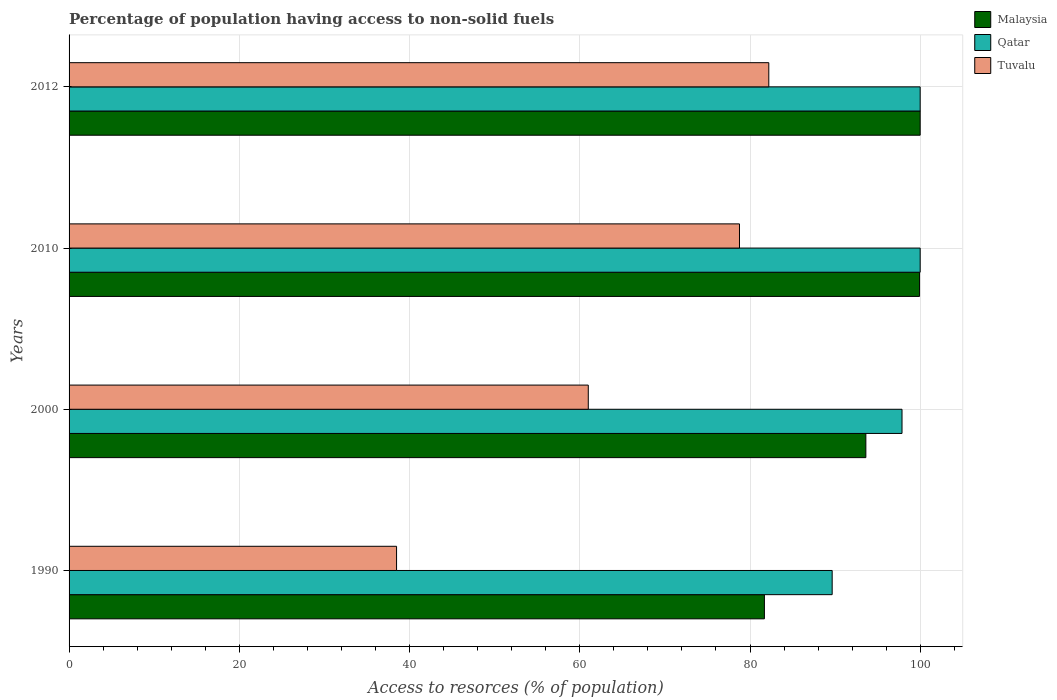How many different coloured bars are there?
Offer a very short reply. 3. How many groups of bars are there?
Provide a short and direct response. 4. How many bars are there on the 4th tick from the top?
Your answer should be very brief. 3. What is the label of the 2nd group of bars from the top?
Provide a short and direct response. 2010. In how many cases, is the number of bars for a given year not equal to the number of legend labels?
Offer a terse response. 0. What is the percentage of population having access to non-solid fuels in Malaysia in 2000?
Ensure brevity in your answer.  93.61. Across all years, what is the maximum percentage of population having access to non-solid fuels in Malaysia?
Provide a succinct answer. 99.99. Across all years, what is the minimum percentage of population having access to non-solid fuels in Tuvalu?
Offer a terse response. 38.47. In which year was the percentage of population having access to non-solid fuels in Qatar maximum?
Ensure brevity in your answer.  2010. In which year was the percentage of population having access to non-solid fuels in Qatar minimum?
Your answer should be compact. 1990. What is the total percentage of population having access to non-solid fuels in Qatar in the graph?
Offer a very short reply. 387.49. What is the difference between the percentage of population having access to non-solid fuels in Qatar in 2010 and that in 2012?
Provide a succinct answer. 0. What is the difference between the percentage of population having access to non-solid fuels in Qatar in 2010 and the percentage of population having access to non-solid fuels in Tuvalu in 2000?
Ensure brevity in your answer.  38.99. What is the average percentage of population having access to non-solid fuels in Malaysia per year?
Offer a terse response. 93.8. In the year 2010, what is the difference between the percentage of population having access to non-solid fuels in Tuvalu and percentage of population having access to non-solid fuels in Malaysia?
Provide a short and direct response. -21.15. In how many years, is the percentage of population having access to non-solid fuels in Tuvalu greater than 80 %?
Provide a succinct answer. 1. What is the ratio of the percentage of population having access to non-solid fuels in Qatar in 2000 to that in 2012?
Your answer should be compact. 0.98. Is the percentage of population having access to non-solid fuels in Malaysia in 2000 less than that in 2012?
Offer a very short reply. Yes. What is the difference between the highest and the second highest percentage of population having access to non-solid fuels in Malaysia?
Make the answer very short. 0.07. What is the difference between the highest and the lowest percentage of population having access to non-solid fuels in Malaysia?
Offer a terse response. 18.3. In how many years, is the percentage of population having access to non-solid fuels in Tuvalu greater than the average percentage of population having access to non-solid fuels in Tuvalu taken over all years?
Offer a very short reply. 2. What does the 3rd bar from the top in 2012 represents?
Give a very brief answer. Malaysia. What does the 1st bar from the bottom in 2010 represents?
Your response must be concise. Malaysia. Is it the case that in every year, the sum of the percentage of population having access to non-solid fuels in Qatar and percentage of population having access to non-solid fuels in Tuvalu is greater than the percentage of population having access to non-solid fuels in Malaysia?
Your answer should be compact. Yes. How many bars are there?
Provide a short and direct response. 12. Are all the bars in the graph horizontal?
Offer a terse response. Yes. What is the difference between two consecutive major ticks on the X-axis?
Offer a terse response. 20. Are the values on the major ticks of X-axis written in scientific E-notation?
Your answer should be compact. No. Does the graph contain grids?
Provide a succinct answer. Yes. Where does the legend appear in the graph?
Your response must be concise. Top right. How are the legend labels stacked?
Ensure brevity in your answer.  Vertical. What is the title of the graph?
Your answer should be very brief. Percentage of population having access to non-solid fuels. What is the label or title of the X-axis?
Provide a short and direct response. Access to resorces (% of population). What is the label or title of the Y-axis?
Make the answer very short. Years. What is the Access to resorces (% of population) of Malaysia in 1990?
Offer a very short reply. 81.69. What is the Access to resorces (% of population) in Qatar in 1990?
Your answer should be compact. 89.65. What is the Access to resorces (% of population) in Tuvalu in 1990?
Provide a succinct answer. 38.47. What is the Access to resorces (% of population) in Malaysia in 2000?
Provide a succinct answer. 93.61. What is the Access to resorces (% of population) in Qatar in 2000?
Make the answer very short. 97.86. What is the Access to resorces (% of population) of Tuvalu in 2000?
Offer a very short reply. 61. What is the Access to resorces (% of population) of Malaysia in 2010?
Your answer should be compact. 99.92. What is the Access to resorces (% of population) in Qatar in 2010?
Make the answer very short. 99.99. What is the Access to resorces (% of population) in Tuvalu in 2010?
Give a very brief answer. 78.76. What is the Access to resorces (% of population) of Malaysia in 2012?
Your response must be concise. 99.99. What is the Access to resorces (% of population) of Qatar in 2012?
Provide a succinct answer. 99.99. What is the Access to resorces (% of population) in Tuvalu in 2012?
Make the answer very short. 82.21. Across all years, what is the maximum Access to resorces (% of population) of Malaysia?
Make the answer very short. 99.99. Across all years, what is the maximum Access to resorces (% of population) in Qatar?
Give a very brief answer. 99.99. Across all years, what is the maximum Access to resorces (% of population) in Tuvalu?
Offer a very short reply. 82.21. Across all years, what is the minimum Access to resorces (% of population) in Malaysia?
Your answer should be compact. 81.69. Across all years, what is the minimum Access to resorces (% of population) of Qatar?
Your answer should be very brief. 89.65. Across all years, what is the minimum Access to resorces (% of population) in Tuvalu?
Keep it short and to the point. 38.47. What is the total Access to resorces (% of population) in Malaysia in the graph?
Give a very brief answer. 375.21. What is the total Access to resorces (% of population) of Qatar in the graph?
Provide a succinct answer. 387.49. What is the total Access to resorces (% of population) in Tuvalu in the graph?
Keep it short and to the point. 260.44. What is the difference between the Access to resorces (% of population) in Malaysia in 1990 and that in 2000?
Your answer should be compact. -11.92. What is the difference between the Access to resorces (% of population) of Qatar in 1990 and that in 2000?
Provide a succinct answer. -8.21. What is the difference between the Access to resorces (% of population) in Tuvalu in 1990 and that in 2000?
Your answer should be compact. -22.52. What is the difference between the Access to resorces (% of population) in Malaysia in 1990 and that in 2010?
Offer a terse response. -18.23. What is the difference between the Access to resorces (% of population) in Qatar in 1990 and that in 2010?
Your answer should be compact. -10.34. What is the difference between the Access to resorces (% of population) of Tuvalu in 1990 and that in 2010?
Offer a very short reply. -40.29. What is the difference between the Access to resorces (% of population) in Malaysia in 1990 and that in 2012?
Offer a very short reply. -18.3. What is the difference between the Access to resorces (% of population) in Qatar in 1990 and that in 2012?
Provide a succinct answer. -10.34. What is the difference between the Access to resorces (% of population) in Tuvalu in 1990 and that in 2012?
Give a very brief answer. -43.73. What is the difference between the Access to resorces (% of population) of Malaysia in 2000 and that in 2010?
Offer a very short reply. -6.31. What is the difference between the Access to resorces (% of population) in Qatar in 2000 and that in 2010?
Make the answer very short. -2.13. What is the difference between the Access to resorces (% of population) in Tuvalu in 2000 and that in 2010?
Provide a succinct answer. -17.76. What is the difference between the Access to resorces (% of population) in Malaysia in 2000 and that in 2012?
Offer a very short reply. -6.38. What is the difference between the Access to resorces (% of population) of Qatar in 2000 and that in 2012?
Your answer should be very brief. -2.13. What is the difference between the Access to resorces (% of population) in Tuvalu in 2000 and that in 2012?
Your answer should be compact. -21.21. What is the difference between the Access to resorces (% of population) of Malaysia in 2010 and that in 2012?
Offer a very short reply. -0.07. What is the difference between the Access to resorces (% of population) of Tuvalu in 2010 and that in 2012?
Your response must be concise. -3.44. What is the difference between the Access to resorces (% of population) in Malaysia in 1990 and the Access to resorces (% of population) in Qatar in 2000?
Offer a very short reply. -16.17. What is the difference between the Access to resorces (% of population) in Malaysia in 1990 and the Access to resorces (% of population) in Tuvalu in 2000?
Keep it short and to the point. 20.69. What is the difference between the Access to resorces (% of population) in Qatar in 1990 and the Access to resorces (% of population) in Tuvalu in 2000?
Your answer should be very brief. 28.65. What is the difference between the Access to resorces (% of population) of Malaysia in 1990 and the Access to resorces (% of population) of Qatar in 2010?
Ensure brevity in your answer.  -18.3. What is the difference between the Access to resorces (% of population) of Malaysia in 1990 and the Access to resorces (% of population) of Tuvalu in 2010?
Your answer should be compact. 2.93. What is the difference between the Access to resorces (% of population) of Qatar in 1990 and the Access to resorces (% of population) of Tuvalu in 2010?
Your answer should be very brief. 10.89. What is the difference between the Access to resorces (% of population) in Malaysia in 1990 and the Access to resorces (% of population) in Qatar in 2012?
Your answer should be compact. -18.3. What is the difference between the Access to resorces (% of population) of Malaysia in 1990 and the Access to resorces (% of population) of Tuvalu in 2012?
Your answer should be compact. -0.51. What is the difference between the Access to resorces (% of population) of Qatar in 1990 and the Access to resorces (% of population) of Tuvalu in 2012?
Your answer should be very brief. 7.45. What is the difference between the Access to resorces (% of population) of Malaysia in 2000 and the Access to resorces (% of population) of Qatar in 2010?
Keep it short and to the point. -6.38. What is the difference between the Access to resorces (% of population) of Malaysia in 2000 and the Access to resorces (% of population) of Tuvalu in 2010?
Keep it short and to the point. 14.85. What is the difference between the Access to resorces (% of population) of Qatar in 2000 and the Access to resorces (% of population) of Tuvalu in 2010?
Offer a very short reply. 19.1. What is the difference between the Access to resorces (% of population) of Malaysia in 2000 and the Access to resorces (% of population) of Qatar in 2012?
Provide a succinct answer. -6.38. What is the difference between the Access to resorces (% of population) of Malaysia in 2000 and the Access to resorces (% of population) of Tuvalu in 2012?
Offer a terse response. 11.4. What is the difference between the Access to resorces (% of population) of Qatar in 2000 and the Access to resorces (% of population) of Tuvalu in 2012?
Ensure brevity in your answer.  15.65. What is the difference between the Access to resorces (% of population) of Malaysia in 2010 and the Access to resorces (% of population) of Qatar in 2012?
Your response must be concise. -0.07. What is the difference between the Access to resorces (% of population) in Malaysia in 2010 and the Access to resorces (% of population) in Tuvalu in 2012?
Ensure brevity in your answer.  17.71. What is the difference between the Access to resorces (% of population) in Qatar in 2010 and the Access to resorces (% of population) in Tuvalu in 2012?
Your answer should be very brief. 17.78. What is the average Access to resorces (% of population) of Malaysia per year?
Your answer should be compact. 93.8. What is the average Access to resorces (% of population) of Qatar per year?
Your answer should be compact. 96.87. What is the average Access to resorces (% of population) of Tuvalu per year?
Your answer should be compact. 65.11. In the year 1990, what is the difference between the Access to resorces (% of population) of Malaysia and Access to resorces (% of population) of Qatar?
Give a very brief answer. -7.96. In the year 1990, what is the difference between the Access to resorces (% of population) of Malaysia and Access to resorces (% of population) of Tuvalu?
Your answer should be very brief. 43.22. In the year 1990, what is the difference between the Access to resorces (% of population) of Qatar and Access to resorces (% of population) of Tuvalu?
Give a very brief answer. 51.18. In the year 2000, what is the difference between the Access to resorces (% of population) in Malaysia and Access to resorces (% of population) in Qatar?
Give a very brief answer. -4.25. In the year 2000, what is the difference between the Access to resorces (% of population) of Malaysia and Access to resorces (% of population) of Tuvalu?
Offer a very short reply. 32.61. In the year 2000, what is the difference between the Access to resorces (% of population) of Qatar and Access to resorces (% of population) of Tuvalu?
Give a very brief answer. 36.86. In the year 2010, what is the difference between the Access to resorces (% of population) of Malaysia and Access to resorces (% of population) of Qatar?
Offer a very short reply. -0.07. In the year 2010, what is the difference between the Access to resorces (% of population) of Malaysia and Access to resorces (% of population) of Tuvalu?
Your response must be concise. 21.15. In the year 2010, what is the difference between the Access to resorces (% of population) of Qatar and Access to resorces (% of population) of Tuvalu?
Ensure brevity in your answer.  21.23. In the year 2012, what is the difference between the Access to resorces (% of population) of Malaysia and Access to resorces (% of population) of Qatar?
Provide a short and direct response. 0. In the year 2012, what is the difference between the Access to resorces (% of population) in Malaysia and Access to resorces (% of population) in Tuvalu?
Make the answer very short. 17.78. In the year 2012, what is the difference between the Access to resorces (% of population) of Qatar and Access to resorces (% of population) of Tuvalu?
Make the answer very short. 17.78. What is the ratio of the Access to resorces (% of population) in Malaysia in 1990 to that in 2000?
Provide a succinct answer. 0.87. What is the ratio of the Access to resorces (% of population) in Qatar in 1990 to that in 2000?
Offer a terse response. 0.92. What is the ratio of the Access to resorces (% of population) in Tuvalu in 1990 to that in 2000?
Your answer should be very brief. 0.63. What is the ratio of the Access to resorces (% of population) of Malaysia in 1990 to that in 2010?
Make the answer very short. 0.82. What is the ratio of the Access to resorces (% of population) of Qatar in 1990 to that in 2010?
Offer a terse response. 0.9. What is the ratio of the Access to resorces (% of population) in Tuvalu in 1990 to that in 2010?
Offer a very short reply. 0.49. What is the ratio of the Access to resorces (% of population) in Malaysia in 1990 to that in 2012?
Give a very brief answer. 0.82. What is the ratio of the Access to resorces (% of population) in Qatar in 1990 to that in 2012?
Your response must be concise. 0.9. What is the ratio of the Access to resorces (% of population) of Tuvalu in 1990 to that in 2012?
Make the answer very short. 0.47. What is the ratio of the Access to resorces (% of population) of Malaysia in 2000 to that in 2010?
Offer a terse response. 0.94. What is the ratio of the Access to resorces (% of population) of Qatar in 2000 to that in 2010?
Offer a terse response. 0.98. What is the ratio of the Access to resorces (% of population) of Tuvalu in 2000 to that in 2010?
Make the answer very short. 0.77. What is the ratio of the Access to resorces (% of population) in Malaysia in 2000 to that in 2012?
Your answer should be very brief. 0.94. What is the ratio of the Access to resorces (% of population) in Qatar in 2000 to that in 2012?
Offer a terse response. 0.98. What is the ratio of the Access to resorces (% of population) in Tuvalu in 2000 to that in 2012?
Your answer should be compact. 0.74. What is the ratio of the Access to resorces (% of population) of Malaysia in 2010 to that in 2012?
Offer a terse response. 1. What is the ratio of the Access to resorces (% of population) of Tuvalu in 2010 to that in 2012?
Offer a terse response. 0.96. What is the difference between the highest and the second highest Access to resorces (% of population) of Malaysia?
Provide a succinct answer. 0.07. What is the difference between the highest and the second highest Access to resorces (% of population) of Qatar?
Provide a short and direct response. 0. What is the difference between the highest and the second highest Access to resorces (% of population) in Tuvalu?
Provide a short and direct response. 3.44. What is the difference between the highest and the lowest Access to resorces (% of population) in Malaysia?
Offer a very short reply. 18.3. What is the difference between the highest and the lowest Access to resorces (% of population) of Qatar?
Make the answer very short. 10.34. What is the difference between the highest and the lowest Access to resorces (% of population) of Tuvalu?
Your response must be concise. 43.73. 